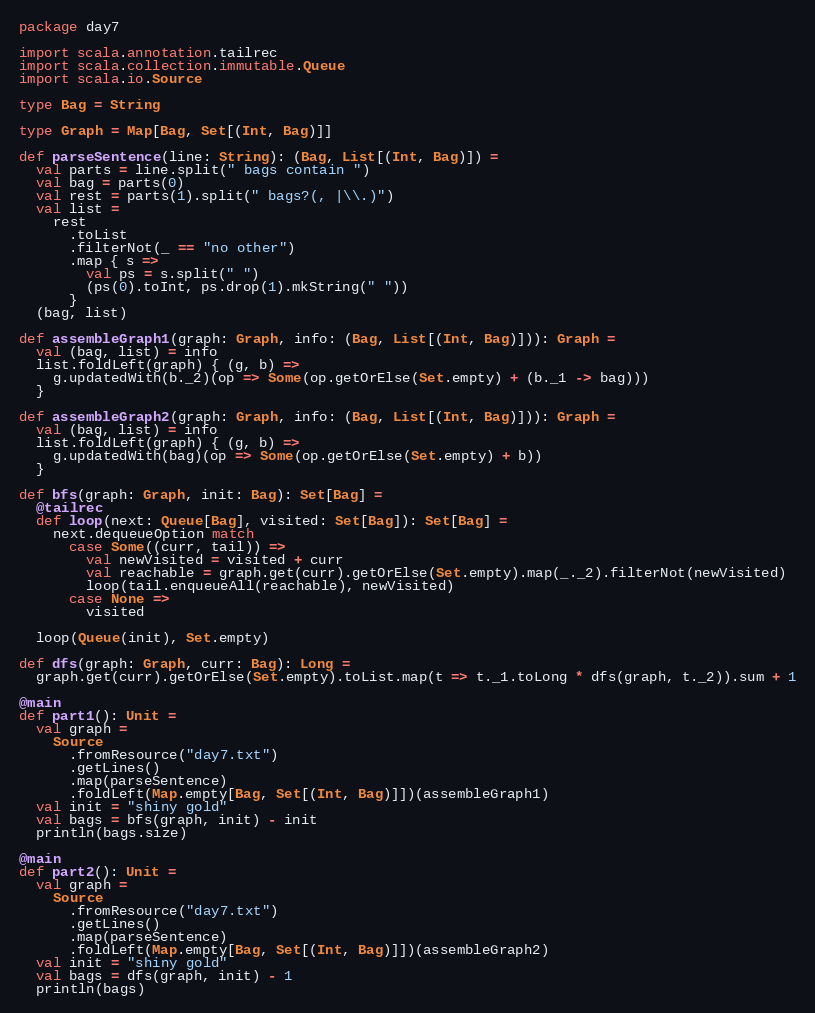<code> <loc_0><loc_0><loc_500><loc_500><_Scala_>package day7

import scala.annotation.tailrec
import scala.collection.immutable.Queue
import scala.io.Source

type Bag = String

type Graph = Map[Bag, Set[(Int, Bag)]]

def parseSentence(line: String): (Bag, List[(Int, Bag)]) =
  val parts = line.split(" bags contain ")
  val bag = parts(0)
  val rest = parts(1).split(" bags?(, |\\.)")
  val list =
    rest
      .toList
      .filterNot(_ == "no other")
      .map { s =>
        val ps = s.split(" ")
        (ps(0).toInt, ps.drop(1).mkString(" "))
      }
  (bag, list)

def assembleGraph1(graph: Graph, info: (Bag, List[(Int, Bag)])): Graph =
  val (bag, list) = info
  list.foldLeft(graph) { (g, b) =>
    g.updatedWith(b._2)(op => Some(op.getOrElse(Set.empty) + (b._1 -> bag)))
  }

def assembleGraph2(graph: Graph, info: (Bag, List[(Int, Bag)])): Graph =
  val (bag, list) = info
  list.foldLeft(graph) { (g, b) =>
    g.updatedWith(bag)(op => Some(op.getOrElse(Set.empty) + b))
  }

def bfs(graph: Graph, init: Bag): Set[Bag] =
  @tailrec
  def loop(next: Queue[Bag], visited: Set[Bag]): Set[Bag] =
    next.dequeueOption match
      case Some((curr, tail)) =>
        val newVisited = visited + curr
        val reachable = graph.get(curr).getOrElse(Set.empty).map(_._2).filterNot(newVisited)
        loop(tail.enqueueAll(reachable), newVisited)
      case None =>
        visited
  
  loop(Queue(init), Set.empty)

def dfs(graph: Graph, curr: Bag): Long =
  graph.get(curr).getOrElse(Set.empty).toList.map(t => t._1.toLong * dfs(graph, t._2)).sum + 1

@main
def part1(): Unit =
  val graph =
    Source
      .fromResource("day7.txt")
      .getLines()
      .map(parseSentence)
      .foldLeft(Map.empty[Bag, Set[(Int, Bag)]])(assembleGraph1)
  val init = "shiny gold"
  val bags = bfs(graph, init) - init
  println(bags.size)

@main
def part2(): Unit =
  val graph =
    Source
      .fromResource("day7.txt")
      .getLines()
      .map(parseSentence)
      .foldLeft(Map.empty[Bag, Set[(Int, Bag)]])(assembleGraph2)
  val init = "shiny gold"
  val bags = dfs(graph, init) - 1
  println(bags)
</code> 